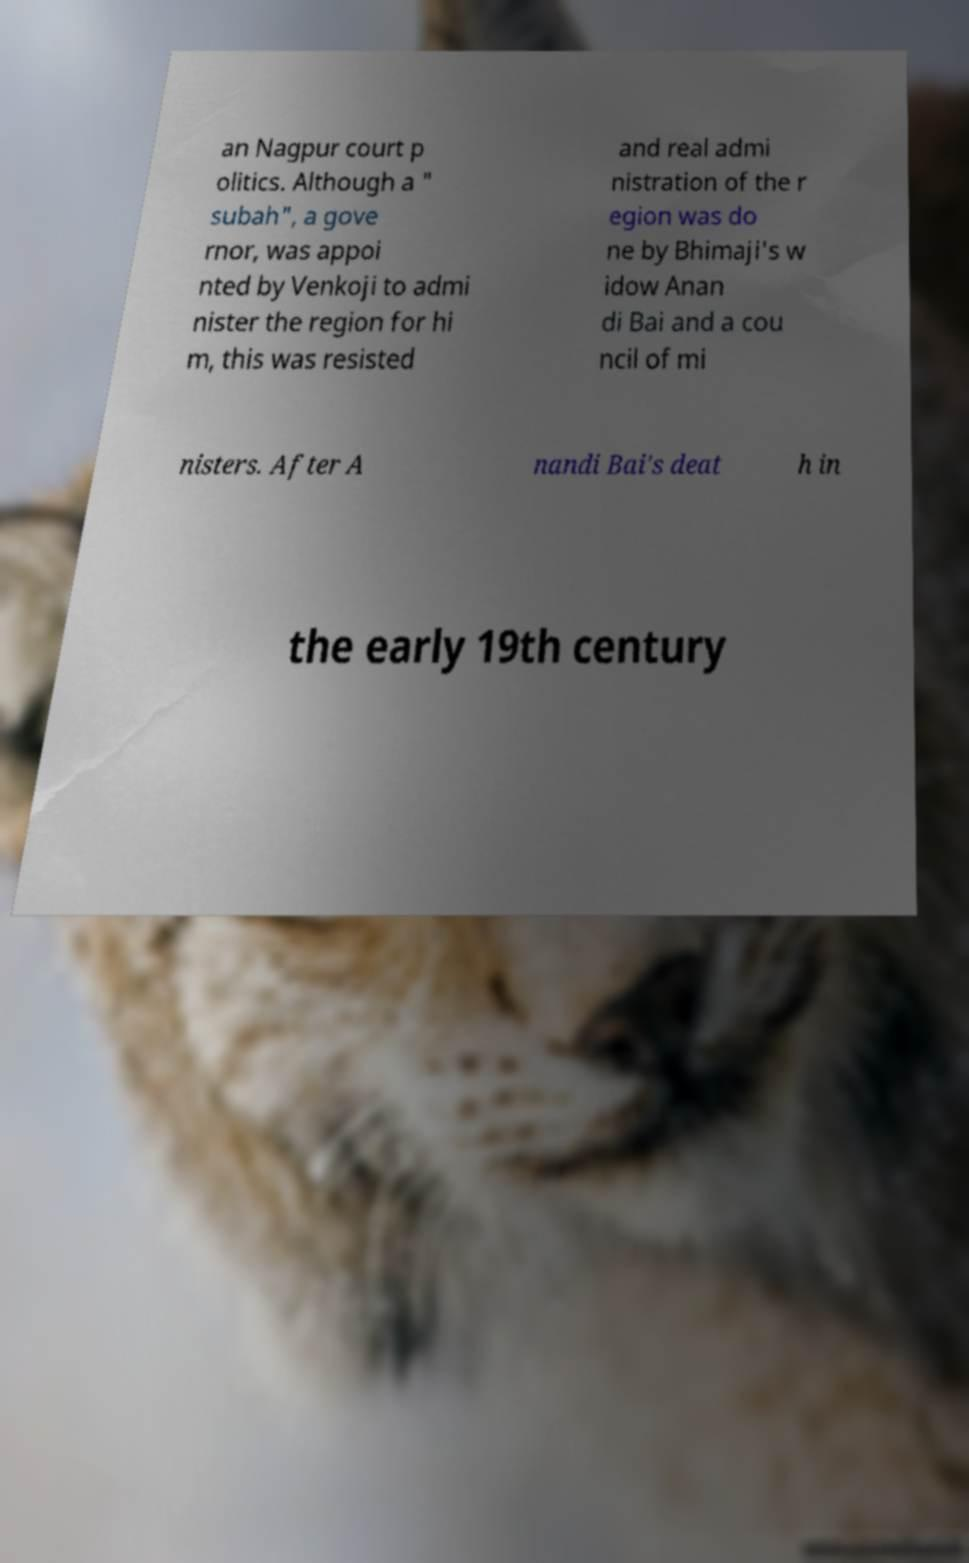Could you assist in decoding the text presented in this image and type it out clearly? an Nagpur court p olitics. Although a " subah", a gove rnor, was appoi nted by Venkoji to admi nister the region for hi m, this was resisted and real admi nistration of the r egion was do ne by Bhimaji's w idow Anan di Bai and a cou ncil of mi nisters. After A nandi Bai's deat h in the early 19th century 